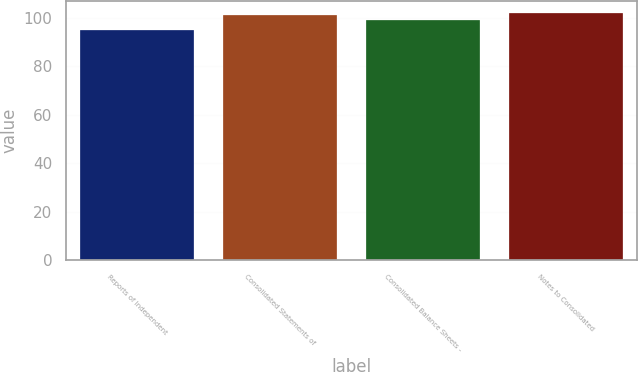Convert chart to OTSL. <chart><loc_0><loc_0><loc_500><loc_500><bar_chart><fcel>Reports of Independent<fcel>Consolidated Statements of<fcel>Consolidated Balance Sheets -<fcel>Notes to Consolidated<nl><fcel>95<fcel>101<fcel>99<fcel>102<nl></chart> 